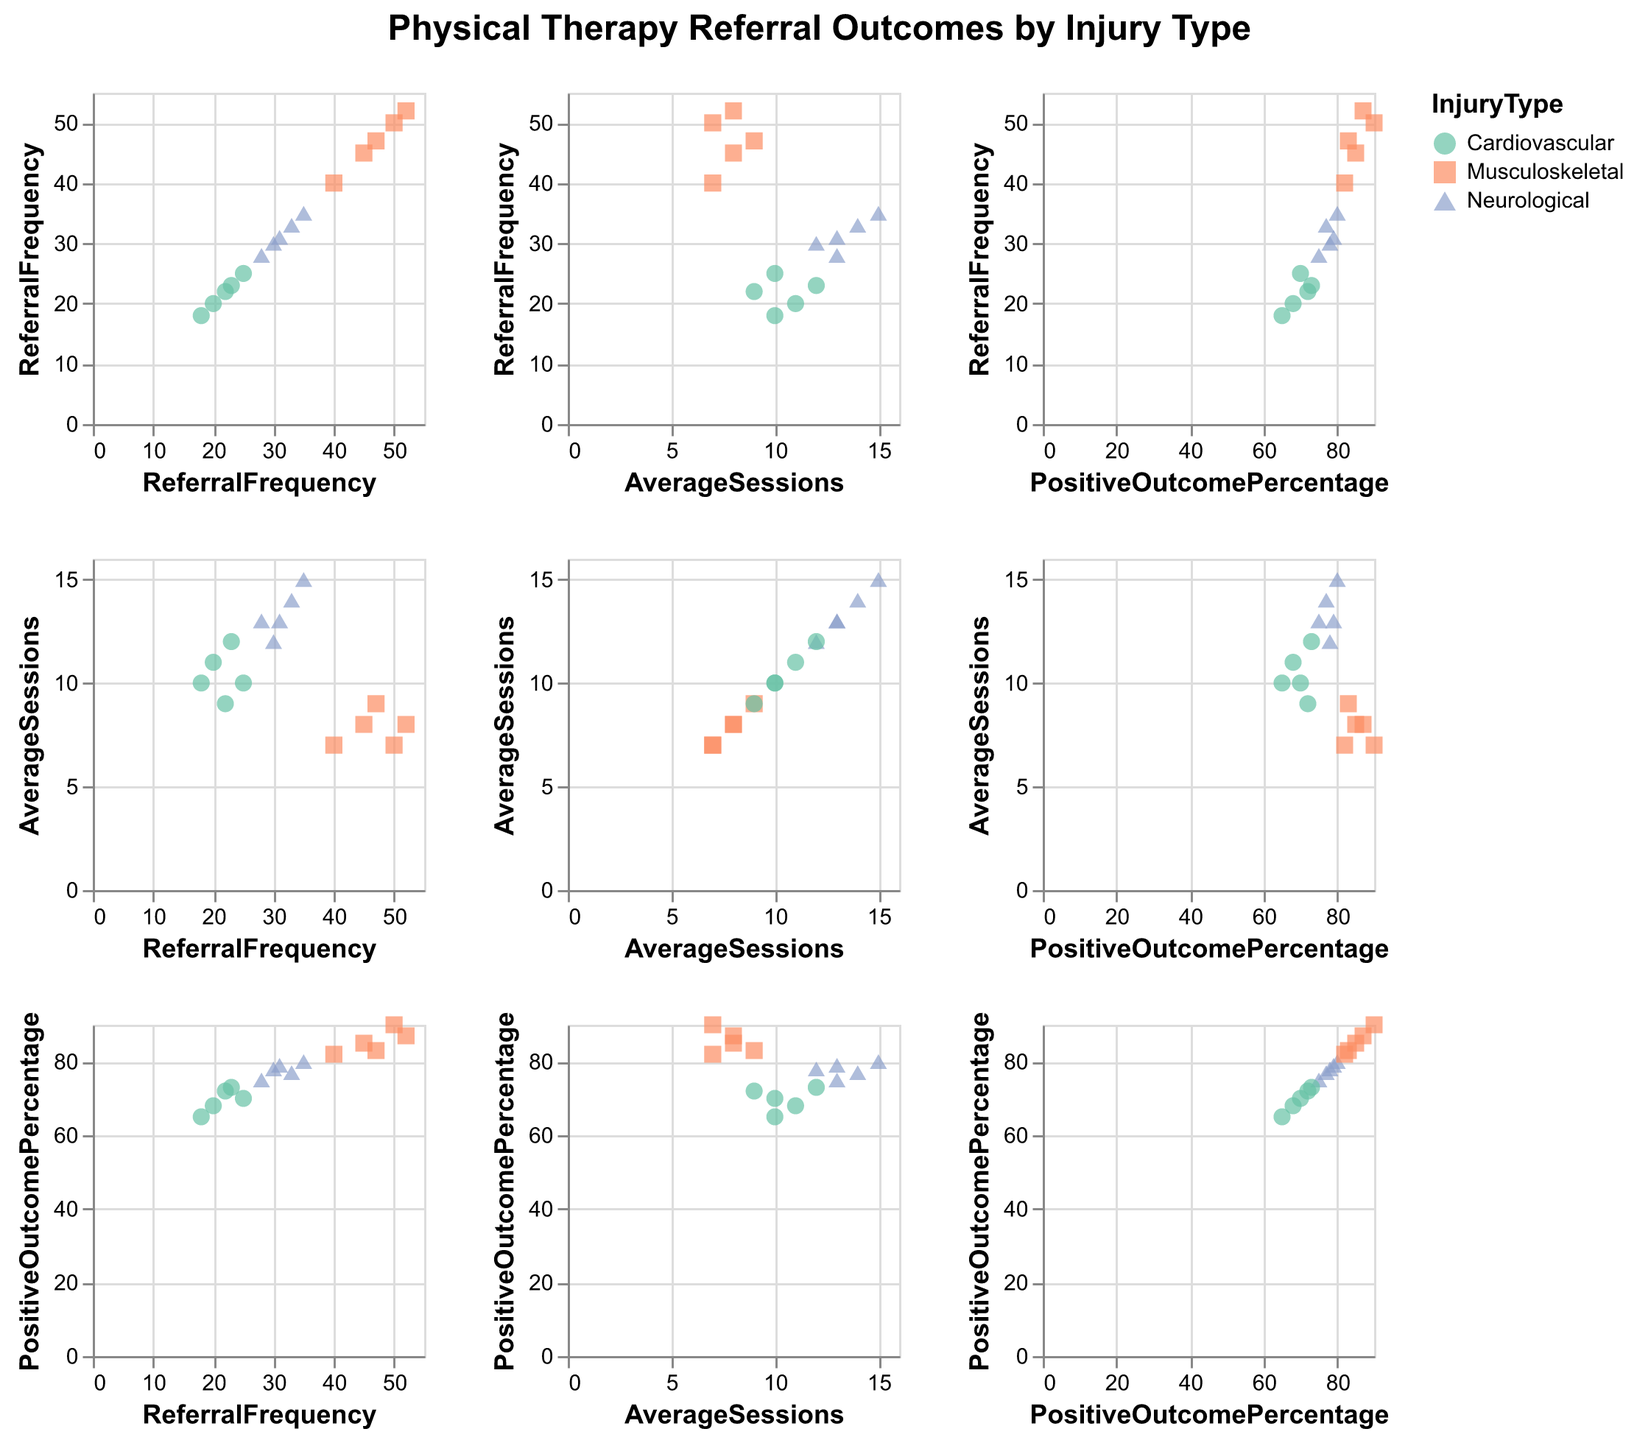What is the title of the figure? The title is usually mentioned at the top of the figure, which provides a general idea about the figure's content. "Physical Therapy Referral Outcomes by Injury Type" is what describes this one.
Answer: Physical Therapy Referral Outcomes by Injury Type How many different injury types are represented in the figure? The color legend usually indicates different categories, which here are visually distinguished by color and shape. There are three distinct colors/shapes corresponding to Musculoskeletal, Neurological, and Cardiovascular.
Answer: 3 Which injury type has the highest positive outcome percentage? In the scatter plot for Positive Outcome Percentage vs. Referral Frequency or Average Sessions, look for the highest y-value (Positive Outcome Percentage). The data point labeled as Musculoskeletal has the highest value of 90%.
Answer: Musculoskeletal What is the range of referral frequency for Cardiovascular injuries? Locate the points associated with Cardiovascular injury type (one distinct color/shape), then identify the minimum and maximum Referral Frequency values on the x-axis. The range is from 18 to 25 based on the data points.
Answer: 18 to 25 What is the average number of sessions for Musculoskeletal injury type? To find the average, gather all the data points for Musculoskeletal and compute the mean of the Average Sessions values: (8 + 7 + 9 + 8 + 7) / 5 = 7.8
Answer: 7.8 How does the average positive outcome percentage for Neurological injuries compare to Cardiovascular injuries? Calculate the mean of Positive Outcome Percentage for both injury types. For Neurological: (78 + 75 + 80 + 77 + 79) / 5 = 77.8. For Cardiovascular: (70 + 68 + 72 + 65 + 73) / 5 = 69.6. Then compare these averages. Neurological has a higher average.
Answer: Neurological > Cardiovascular Does a higher average number of sessions correlate with a higher positive outcome percentage for any injury type? Look for patterns between Average Sessions and Positive Outcome Percentage for each injury type. Neurological shows a slight upward trend, while others don't clearly correlate.
Answer: Slightly for Neurological Which injury type shows the most variability in referral frequency? Variability can be evaluated by observing the spread of points along the Referral Frequency axis for each injury type. Musculoskeletal has the widest spread from 40 to 52.
Answer: Musculoskeletal In which plot do Neurological injuries have their densest clustering? Observing the scatter plots, Neurological injuries appear densely clustered around the Average Sessions vs. Positive Outcome Percentage with a tight grouping between 12-15 sessions and positive outcomes between 75-80%.
Answer: Average Sessions vs. Positive Outcome Percentage What is the trend between referral frequency and positive outcome percentage for Musculoskeletal injuries? By observing points for Musculoskeletal in the Referral Frequency vs. Positive Outcome Percentage plot, a positive trend can be noticed where more frequent referrals correspond to higher positive outcomes.
Answer: Positive trend 